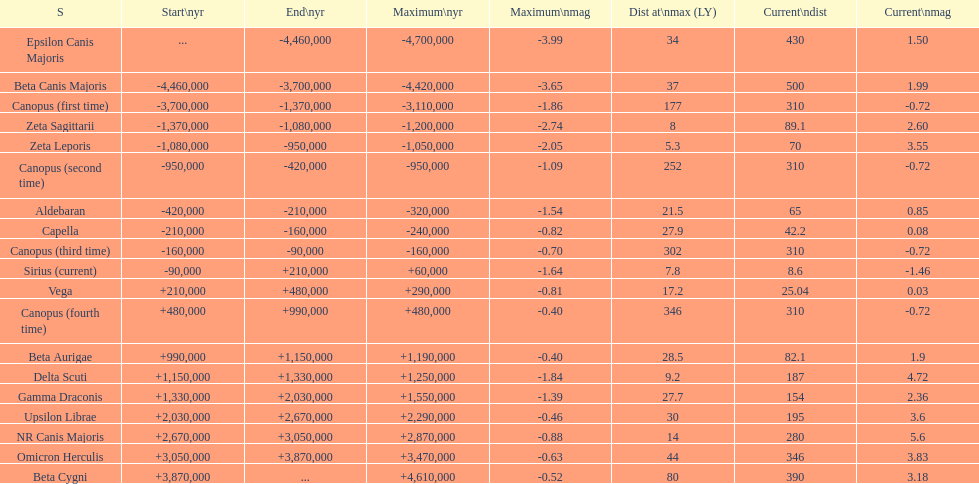How many stars have a distance at maximum of 30 light years or higher? 9. 